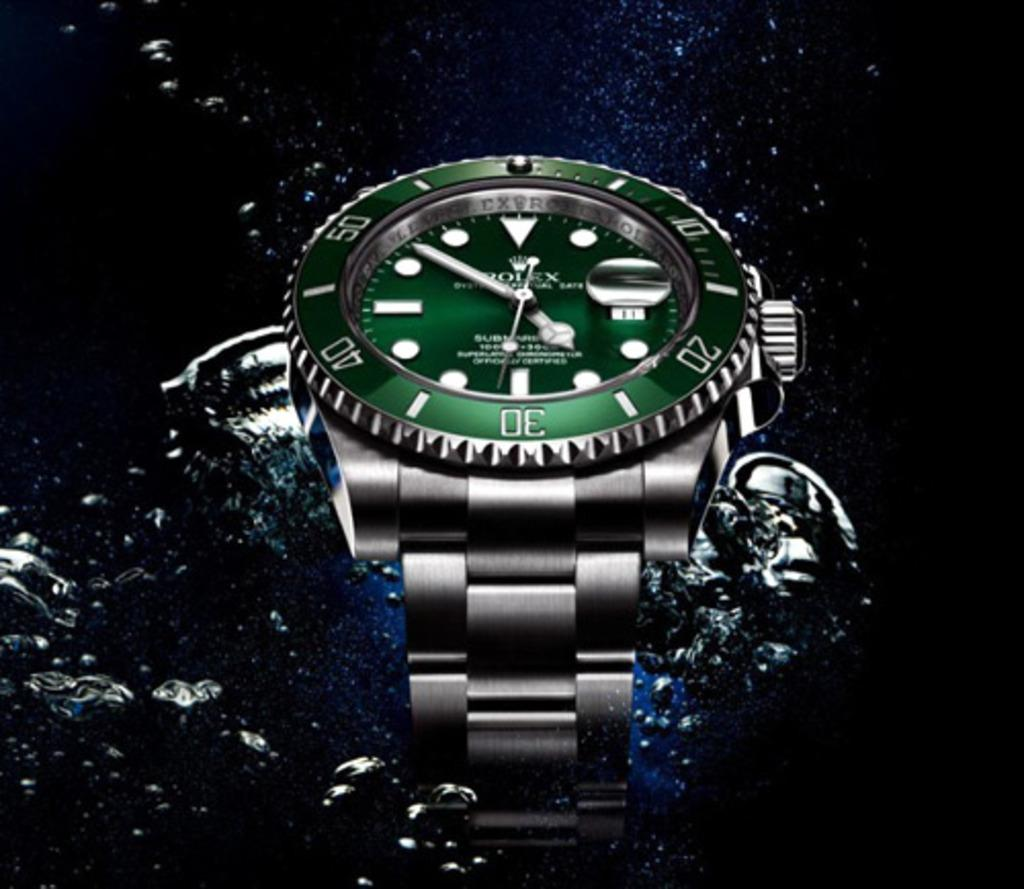<image>
Create a compact narrative representing the image presented. A silver and green watch with the number 30. 